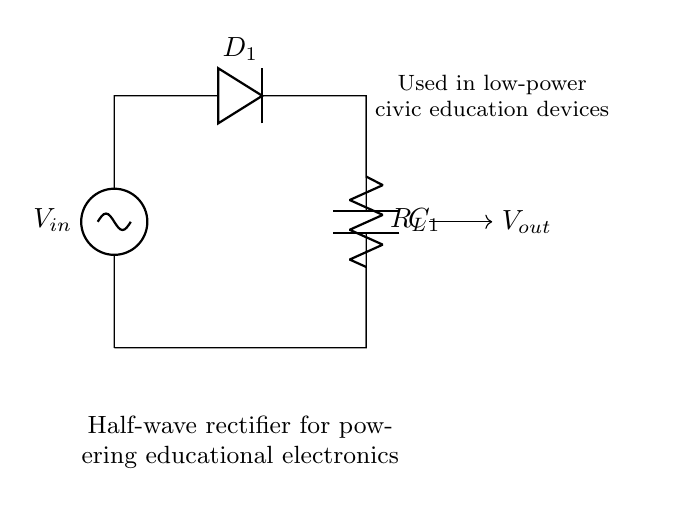What is the type of rectifier shown in the circuit? The circuit diagram illustrates a half-wave rectifier, which is characterized by the use of a single diode to allow current to pass during one half of the input waveform.
Answer: half-wave What component is used to store charge in the circuit? The capacitor labeled C1 is responsible for storing charge in the circuit. It smooths out the output voltage after rectification.
Answer: C1 How many diodes are present in this rectifier circuit? The circuit includes a single diode, D1, which is used to convert AC voltage to DC voltage by allowing current flow in only one direction.
Answer: one What does the load resistor R_L do in this circuit? The load resistor R_L represents the component that consumes power in the circuit. It is where the rectified voltage is applied for educational electronics.
Answer: consumes power What is the function of the diode D1 in this circuit? The diode D1 allows current to flow only during the positive half-cycles of the input voltage, blocking the negative half-cycles, which is essential for converting AC to DC.
Answer: convert AC to DC What happens to the output voltage when the input voltage is negative? When the input voltage is negative, the diode D1 becomes reverse-biased and prevents current flow, resulting in a zero output voltage during that period.
Answer: zero output voltage What is the overall effect of the capacitor C1 in this half-wave rectifier circuit? The capacitor C1 smooths the output voltage by charging during the positive half-cycle and discharging slowly during the zero output period, providing a more stable DC voltage.
Answer: smooth output voltage 